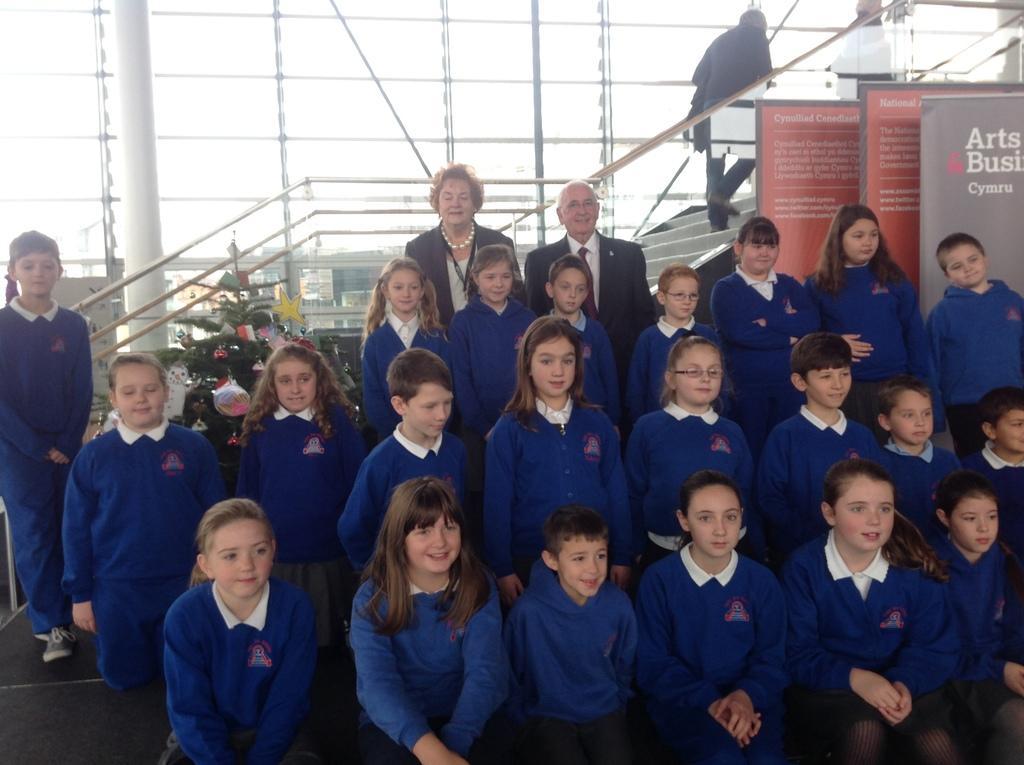Could you give a brief overview of what you see in this image? In the picture we can see a group of school students with blue color uniform and behind them, we can see a man and a woman standing, they are in blazers and behind them, we can see a railing with stairs and near it we can see some hoardings and in the background we can see a glass wall with poles to it. 